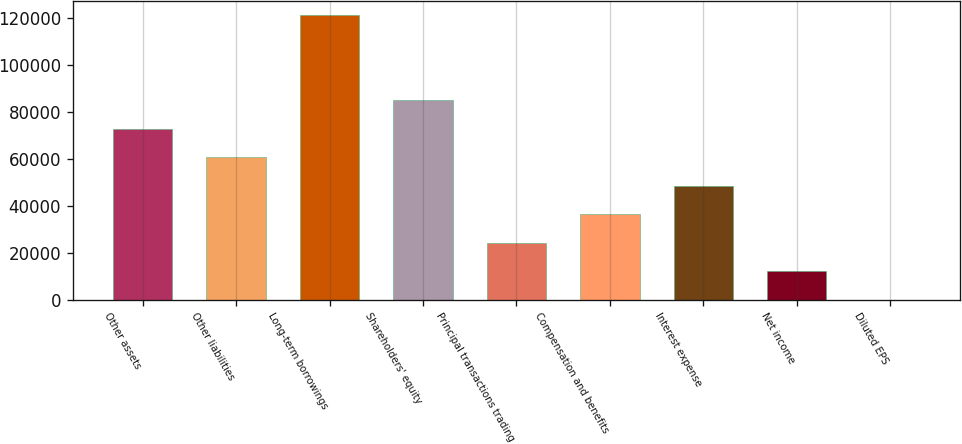<chart> <loc_0><loc_0><loc_500><loc_500><bar_chart><fcel>Other assets<fcel>Other liabilities<fcel>Long-term borrowings<fcel>Shareholders' equity<fcel>Principal transactions trading<fcel>Compensation and benefits<fcel>Interest expense<fcel>Net income<fcel>Diluted EPS<nl><fcel>72837.6<fcel>60698.2<fcel>121395<fcel>84976.9<fcel>24280.2<fcel>36419.5<fcel>48558.9<fcel>12140.8<fcel>1.47<nl></chart> 